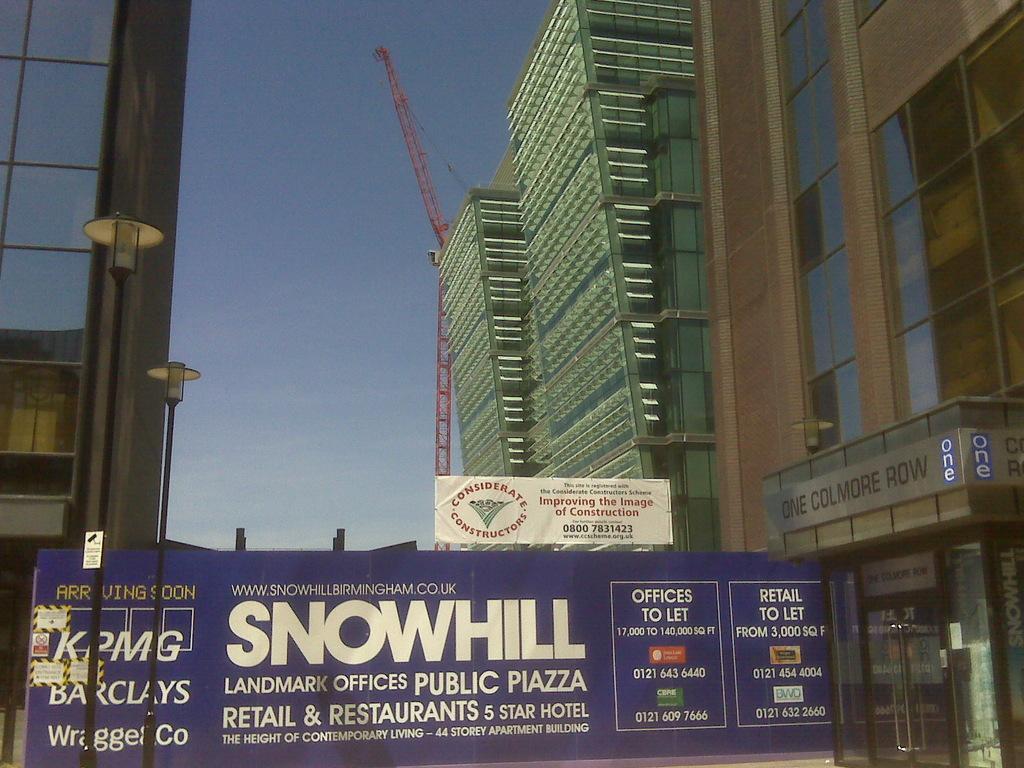Describe this image in one or two sentences. In this image, we can see buildings, poles, banners, lights, crane, glass doors. Background there is a clear sky. 